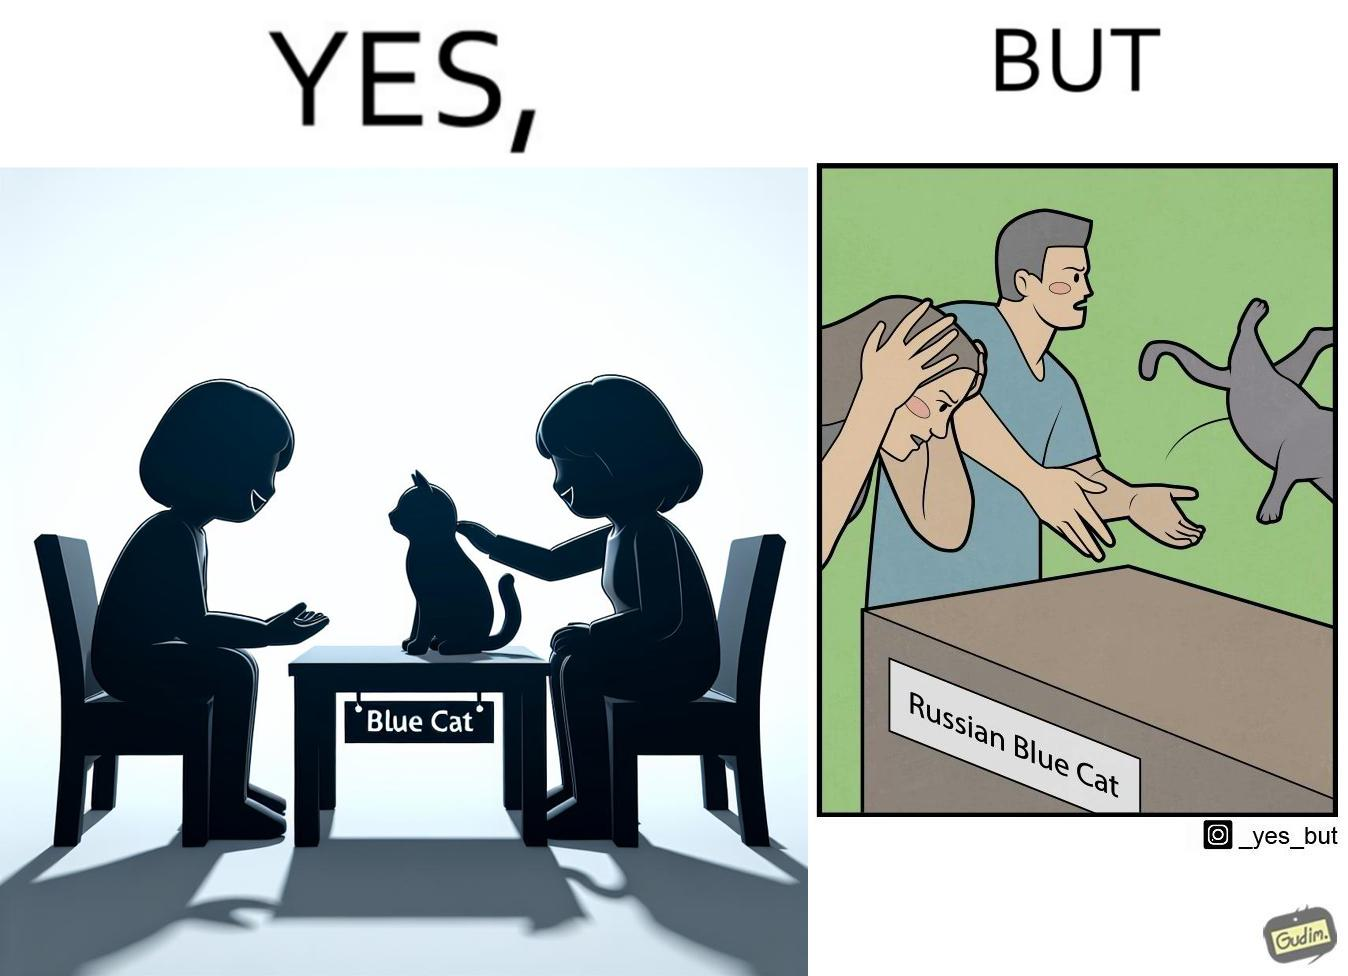What is shown in the left half versus the right half of this image? In the left part of the image: two happy people, where one of them is petting a cat sitting on a table, with a label "Blue Cat" written on the tabel. In the right part of the image: a worried person with hands on her head looking at a table with the label "Russian Blue Cat", while another angry person seems to be throwing away a cat. 